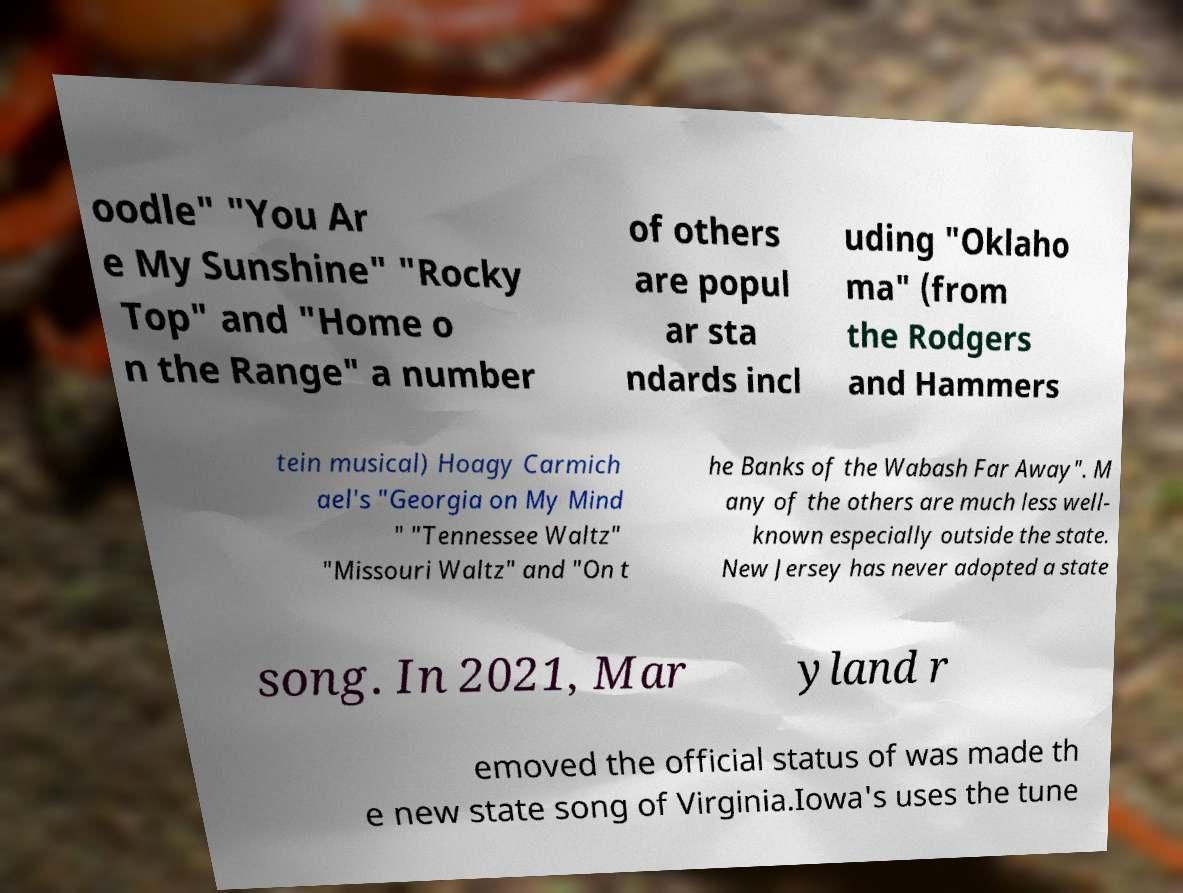Could you assist in decoding the text presented in this image and type it out clearly? oodle" "You Ar e My Sunshine" "Rocky Top" and "Home o n the Range" a number of others are popul ar sta ndards incl uding "Oklaho ma" (from the Rodgers and Hammers tein musical) Hoagy Carmich ael's "Georgia on My Mind " "Tennessee Waltz" "Missouri Waltz" and "On t he Banks of the Wabash Far Away". M any of the others are much less well- known especially outside the state. New Jersey has never adopted a state song. In 2021, Mar yland r emoved the official status of was made th e new state song of Virginia.Iowa's uses the tune 